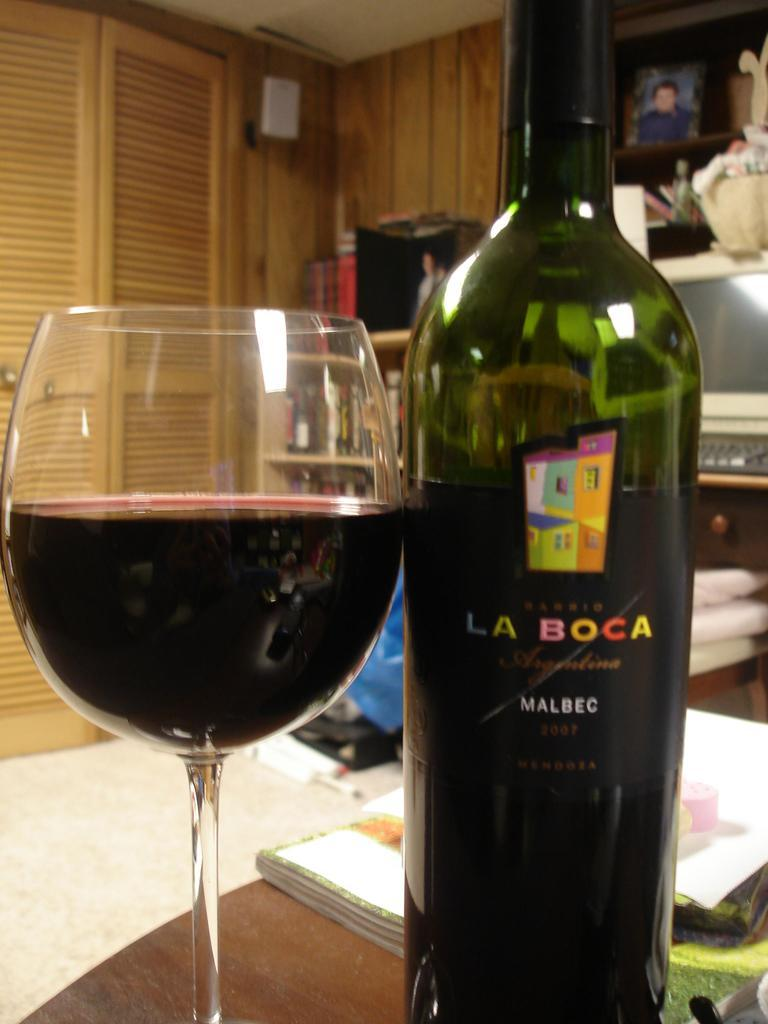What type of glass is visible in the image? There is a wine glass in the image. What is placed alongside the wine glass? There is a bottle in the image. Where are the wine glass and the bottle located? Both the wine glass and the bottle are placed on a table. What else can be found on the table? There is a book on the table. What can be seen in the background of the image? There is a computer, a photo, and a wall in the background of the image. What type of chalk is being used to draw on the wall in the image? There is no chalk or drawing on the wall in the image. Is there a fight happening between the people in the image? There are no people visible in the image, so it is impossible to determine if a fight is happening. 